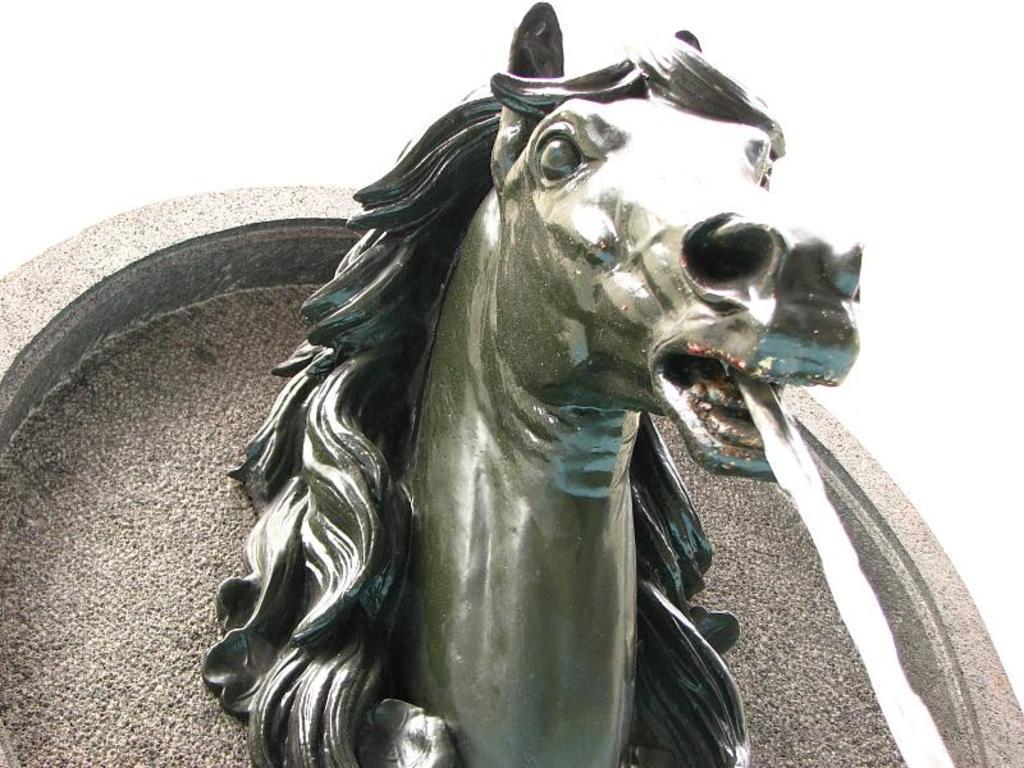In one or two sentences, can you explain what this image depicts? In this image, in the middle, we can see a sculpture from the mouth of the sculpture, we can see water flowing. In the background, we can see a floor. In the background, we can also see white color. 